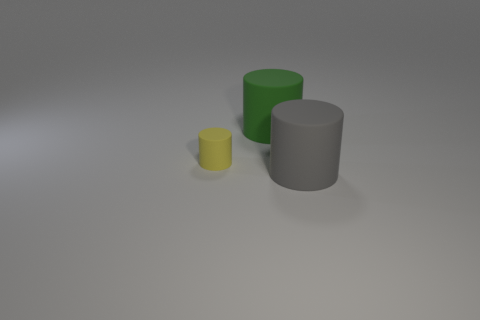What can you tell me about the lighting in this scene? The lighting in the image is soft and diffuse, coming from above. It casts gentle shadows under the cylinders, suggesting an ambient light source, possibly emulating an overcast day or studio lighting. 